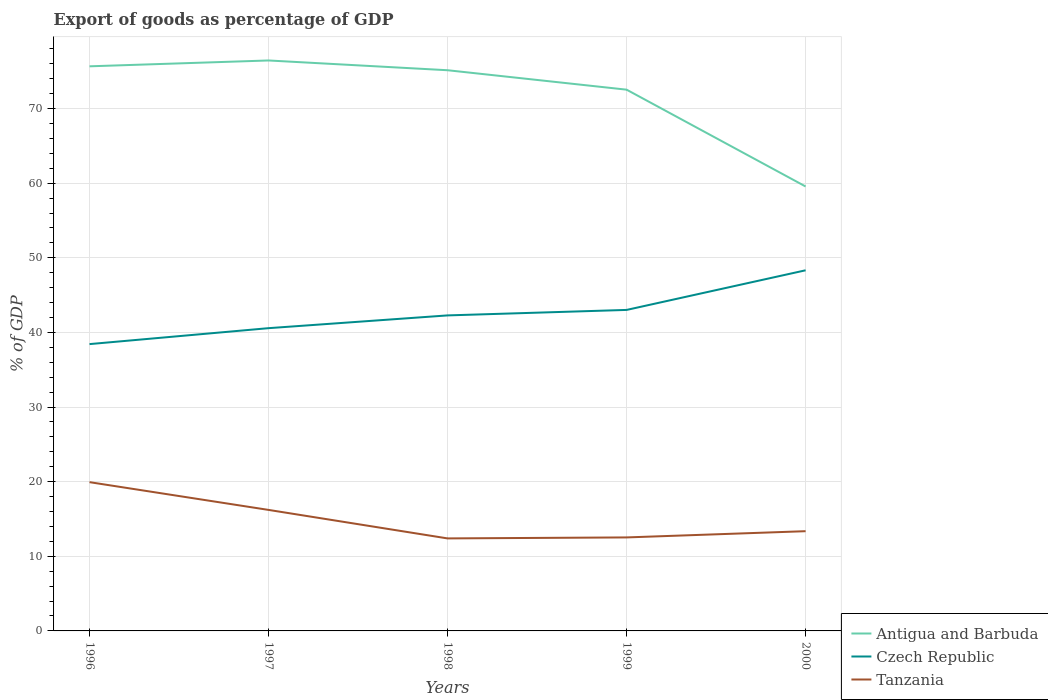How many different coloured lines are there?
Your answer should be compact. 3. Is the number of lines equal to the number of legend labels?
Provide a short and direct response. Yes. Across all years, what is the maximum export of goods as percentage of GDP in Antigua and Barbuda?
Offer a terse response. 59.56. In which year was the export of goods as percentage of GDP in Antigua and Barbuda maximum?
Ensure brevity in your answer.  2000. What is the total export of goods as percentage of GDP in Antigua and Barbuda in the graph?
Give a very brief answer. 3.91. What is the difference between the highest and the second highest export of goods as percentage of GDP in Tanzania?
Offer a very short reply. 7.54. Is the export of goods as percentage of GDP in Tanzania strictly greater than the export of goods as percentage of GDP in Antigua and Barbuda over the years?
Offer a very short reply. Yes. How many lines are there?
Your answer should be compact. 3. What is the difference between two consecutive major ticks on the Y-axis?
Your answer should be very brief. 10. Where does the legend appear in the graph?
Keep it short and to the point. Bottom right. What is the title of the graph?
Your answer should be very brief. Export of goods as percentage of GDP. Does "Vietnam" appear as one of the legend labels in the graph?
Provide a short and direct response. No. What is the label or title of the X-axis?
Ensure brevity in your answer.  Years. What is the label or title of the Y-axis?
Give a very brief answer. % of GDP. What is the % of GDP of Antigua and Barbuda in 1996?
Your answer should be very brief. 75.67. What is the % of GDP in Czech Republic in 1996?
Ensure brevity in your answer.  38.44. What is the % of GDP in Tanzania in 1996?
Your answer should be very brief. 19.94. What is the % of GDP of Antigua and Barbuda in 1997?
Provide a succinct answer. 76.45. What is the % of GDP in Czech Republic in 1997?
Give a very brief answer. 40.57. What is the % of GDP in Tanzania in 1997?
Make the answer very short. 16.22. What is the % of GDP of Antigua and Barbuda in 1998?
Make the answer very short. 75.14. What is the % of GDP of Czech Republic in 1998?
Your response must be concise. 42.28. What is the % of GDP in Tanzania in 1998?
Give a very brief answer. 12.4. What is the % of GDP in Antigua and Barbuda in 1999?
Provide a succinct answer. 72.54. What is the % of GDP of Czech Republic in 1999?
Ensure brevity in your answer.  43.02. What is the % of GDP in Tanzania in 1999?
Offer a very short reply. 12.53. What is the % of GDP in Antigua and Barbuda in 2000?
Your answer should be compact. 59.56. What is the % of GDP of Czech Republic in 2000?
Make the answer very short. 48.33. What is the % of GDP in Tanzania in 2000?
Provide a succinct answer. 13.36. Across all years, what is the maximum % of GDP of Antigua and Barbuda?
Your answer should be very brief. 76.45. Across all years, what is the maximum % of GDP of Czech Republic?
Offer a very short reply. 48.33. Across all years, what is the maximum % of GDP in Tanzania?
Your answer should be very brief. 19.94. Across all years, what is the minimum % of GDP of Antigua and Barbuda?
Keep it short and to the point. 59.56. Across all years, what is the minimum % of GDP of Czech Republic?
Your response must be concise. 38.44. Across all years, what is the minimum % of GDP of Tanzania?
Provide a succinct answer. 12.4. What is the total % of GDP in Antigua and Barbuda in the graph?
Offer a terse response. 359.35. What is the total % of GDP in Czech Republic in the graph?
Offer a very short reply. 212.64. What is the total % of GDP of Tanzania in the graph?
Your response must be concise. 74.45. What is the difference between the % of GDP in Antigua and Barbuda in 1996 and that in 1997?
Your answer should be compact. -0.78. What is the difference between the % of GDP in Czech Republic in 1996 and that in 1997?
Ensure brevity in your answer.  -2.14. What is the difference between the % of GDP in Tanzania in 1996 and that in 1997?
Give a very brief answer. 3.72. What is the difference between the % of GDP in Antigua and Barbuda in 1996 and that in 1998?
Offer a very short reply. 0.53. What is the difference between the % of GDP in Czech Republic in 1996 and that in 1998?
Your response must be concise. -3.85. What is the difference between the % of GDP in Tanzania in 1996 and that in 1998?
Keep it short and to the point. 7.54. What is the difference between the % of GDP of Antigua and Barbuda in 1996 and that in 1999?
Offer a very short reply. 3.13. What is the difference between the % of GDP of Czech Republic in 1996 and that in 1999?
Ensure brevity in your answer.  -4.58. What is the difference between the % of GDP in Tanzania in 1996 and that in 1999?
Give a very brief answer. 7.41. What is the difference between the % of GDP of Antigua and Barbuda in 1996 and that in 2000?
Offer a very short reply. 16.1. What is the difference between the % of GDP of Czech Republic in 1996 and that in 2000?
Your response must be concise. -9.89. What is the difference between the % of GDP in Tanzania in 1996 and that in 2000?
Provide a short and direct response. 6.57. What is the difference between the % of GDP in Antigua and Barbuda in 1997 and that in 1998?
Your response must be concise. 1.31. What is the difference between the % of GDP of Czech Republic in 1997 and that in 1998?
Your response must be concise. -1.71. What is the difference between the % of GDP in Tanzania in 1997 and that in 1998?
Your answer should be very brief. 3.82. What is the difference between the % of GDP of Antigua and Barbuda in 1997 and that in 1999?
Make the answer very short. 3.91. What is the difference between the % of GDP of Czech Republic in 1997 and that in 1999?
Provide a succinct answer. -2.44. What is the difference between the % of GDP of Tanzania in 1997 and that in 1999?
Provide a short and direct response. 3.69. What is the difference between the % of GDP of Antigua and Barbuda in 1997 and that in 2000?
Your response must be concise. 16.89. What is the difference between the % of GDP in Czech Republic in 1997 and that in 2000?
Give a very brief answer. -7.76. What is the difference between the % of GDP of Tanzania in 1997 and that in 2000?
Make the answer very short. 2.85. What is the difference between the % of GDP of Antigua and Barbuda in 1998 and that in 1999?
Your answer should be compact. 2.6. What is the difference between the % of GDP of Czech Republic in 1998 and that in 1999?
Give a very brief answer. -0.74. What is the difference between the % of GDP of Tanzania in 1998 and that in 1999?
Keep it short and to the point. -0.13. What is the difference between the % of GDP of Antigua and Barbuda in 1998 and that in 2000?
Offer a very short reply. 15.58. What is the difference between the % of GDP in Czech Republic in 1998 and that in 2000?
Offer a terse response. -6.05. What is the difference between the % of GDP in Tanzania in 1998 and that in 2000?
Keep it short and to the point. -0.97. What is the difference between the % of GDP in Antigua and Barbuda in 1999 and that in 2000?
Make the answer very short. 12.98. What is the difference between the % of GDP of Czech Republic in 1999 and that in 2000?
Your response must be concise. -5.31. What is the difference between the % of GDP in Tanzania in 1999 and that in 2000?
Your response must be concise. -0.84. What is the difference between the % of GDP in Antigua and Barbuda in 1996 and the % of GDP in Czech Republic in 1997?
Your response must be concise. 35.09. What is the difference between the % of GDP in Antigua and Barbuda in 1996 and the % of GDP in Tanzania in 1997?
Your response must be concise. 59.45. What is the difference between the % of GDP in Czech Republic in 1996 and the % of GDP in Tanzania in 1997?
Your answer should be compact. 22.22. What is the difference between the % of GDP in Antigua and Barbuda in 1996 and the % of GDP in Czech Republic in 1998?
Offer a terse response. 33.38. What is the difference between the % of GDP of Antigua and Barbuda in 1996 and the % of GDP of Tanzania in 1998?
Provide a short and direct response. 63.27. What is the difference between the % of GDP of Czech Republic in 1996 and the % of GDP of Tanzania in 1998?
Provide a succinct answer. 26.04. What is the difference between the % of GDP in Antigua and Barbuda in 1996 and the % of GDP in Czech Republic in 1999?
Keep it short and to the point. 32.65. What is the difference between the % of GDP in Antigua and Barbuda in 1996 and the % of GDP in Tanzania in 1999?
Your response must be concise. 63.14. What is the difference between the % of GDP in Czech Republic in 1996 and the % of GDP in Tanzania in 1999?
Your response must be concise. 25.91. What is the difference between the % of GDP of Antigua and Barbuda in 1996 and the % of GDP of Czech Republic in 2000?
Ensure brevity in your answer.  27.34. What is the difference between the % of GDP in Antigua and Barbuda in 1996 and the % of GDP in Tanzania in 2000?
Your answer should be compact. 62.3. What is the difference between the % of GDP of Czech Republic in 1996 and the % of GDP of Tanzania in 2000?
Your response must be concise. 25.07. What is the difference between the % of GDP of Antigua and Barbuda in 1997 and the % of GDP of Czech Republic in 1998?
Keep it short and to the point. 34.17. What is the difference between the % of GDP of Antigua and Barbuda in 1997 and the % of GDP of Tanzania in 1998?
Ensure brevity in your answer.  64.05. What is the difference between the % of GDP in Czech Republic in 1997 and the % of GDP in Tanzania in 1998?
Provide a succinct answer. 28.18. What is the difference between the % of GDP in Antigua and Barbuda in 1997 and the % of GDP in Czech Republic in 1999?
Offer a terse response. 33.43. What is the difference between the % of GDP in Antigua and Barbuda in 1997 and the % of GDP in Tanzania in 1999?
Offer a terse response. 63.92. What is the difference between the % of GDP of Czech Republic in 1997 and the % of GDP of Tanzania in 1999?
Make the answer very short. 28.04. What is the difference between the % of GDP in Antigua and Barbuda in 1997 and the % of GDP in Czech Republic in 2000?
Your answer should be very brief. 28.12. What is the difference between the % of GDP of Antigua and Barbuda in 1997 and the % of GDP of Tanzania in 2000?
Provide a succinct answer. 63.08. What is the difference between the % of GDP in Czech Republic in 1997 and the % of GDP in Tanzania in 2000?
Give a very brief answer. 27.21. What is the difference between the % of GDP of Antigua and Barbuda in 1998 and the % of GDP of Czech Republic in 1999?
Your answer should be compact. 32.12. What is the difference between the % of GDP in Antigua and Barbuda in 1998 and the % of GDP in Tanzania in 1999?
Offer a very short reply. 62.61. What is the difference between the % of GDP in Czech Republic in 1998 and the % of GDP in Tanzania in 1999?
Your response must be concise. 29.75. What is the difference between the % of GDP of Antigua and Barbuda in 1998 and the % of GDP of Czech Republic in 2000?
Offer a terse response. 26.81. What is the difference between the % of GDP of Antigua and Barbuda in 1998 and the % of GDP of Tanzania in 2000?
Keep it short and to the point. 61.78. What is the difference between the % of GDP of Czech Republic in 1998 and the % of GDP of Tanzania in 2000?
Your response must be concise. 28.92. What is the difference between the % of GDP in Antigua and Barbuda in 1999 and the % of GDP in Czech Republic in 2000?
Your answer should be very brief. 24.21. What is the difference between the % of GDP of Antigua and Barbuda in 1999 and the % of GDP of Tanzania in 2000?
Ensure brevity in your answer.  59.17. What is the difference between the % of GDP of Czech Republic in 1999 and the % of GDP of Tanzania in 2000?
Make the answer very short. 29.65. What is the average % of GDP in Antigua and Barbuda per year?
Provide a succinct answer. 71.87. What is the average % of GDP of Czech Republic per year?
Offer a terse response. 42.53. What is the average % of GDP of Tanzania per year?
Ensure brevity in your answer.  14.89. In the year 1996, what is the difference between the % of GDP of Antigua and Barbuda and % of GDP of Czech Republic?
Offer a very short reply. 37.23. In the year 1996, what is the difference between the % of GDP in Antigua and Barbuda and % of GDP in Tanzania?
Ensure brevity in your answer.  55.73. In the year 1996, what is the difference between the % of GDP in Czech Republic and % of GDP in Tanzania?
Ensure brevity in your answer.  18.5. In the year 1997, what is the difference between the % of GDP of Antigua and Barbuda and % of GDP of Czech Republic?
Give a very brief answer. 35.88. In the year 1997, what is the difference between the % of GDP in Antigua and Barbuda and % of GDP in Tanzania?
Your answer should be very brief. 60.23. In the year 1997, what is the difference between the % of GDP of Czech Republic and % of GDP of Tanzania?
Provide a succinct answer. 24.36. In the year 1998, what is the difference between the % of GDP in Antigua and Barbuda and % of GDP in Czech Republic?
Offer a terse response. 32.86. In the year 1998, what is the difference between the % of GDP in Antigua and Barbuda and % of GDP in Tanzania?
Keep it short and to the point. 62.74. In the year 1998, what is the difference between the % of GDP of Czech Republic and % of GDP of Tanzania?
Ensure brevity in your answer.  29.89. In the year 1999, what is the difference between the % of GDP of Antigua and Barbuda and % of GDP of Czech Republic?
Give a very brief answer. 29.52. In the year 1999, what is the difference between the % of GDP in Antigua and Barbuda and % of GDP in Tanzania?
Offer a terse response. 60.01. In the year 1999, what is the difference between the % of GDP of Czech Republic and % of GDP of Tanzania?
Keep it short and to the point. 30.49. In the year 2000, what is the difference between the % of GDP of Antigua and Barbuda and % of GDP of Czech Republic?
Your answer should be compact. 11.23. In the year 2000, what is the difference between the % of GDP of Antigua and Barbuda and % of GDP of Tanzania?
Your answer should be very brief. 46.2. In the year 2000, what is the difference between the % of GDP of Czech Republic and % of GDP of Tanzania?
Offer a terse response. 34.96. What is the ratio of the % of GDP in Antigua and Barbuda in 1996 to that in 1997?
Give a very brief answer. 0.99. What is the ratio of the % of GDP of Czech Republic in 1996 to that in 1997?
Your answer should be compact. 0.95. What is the ratio of the % of GDP of Tanzania in 1996 to that in 1997?
Offer a very short reply. 1.23. What is the ratio of the % of GDP of Antigua and Barbuda in 1996 to that in 1998?
Make the answer very short. 1.01. What is the ratio of the % of GDP in Tanzania in 1996 to that in 1998?
Ensure brevity in your answer.  1.61. What is the ratio of the % of GDP in Antigua and Barbuda in 1996 to that in 1999?
Make the answer very short. 1.04. What is the ratio of the % of GDP in Czech Republic in 1996 to that in 1999?
Offer a terse response. 0.89. What is the ratio of the % of GDP of Tanzania in 1996 to that in 1999?
Make the answer very short. 1.59. What is the ratio of the % of GDP of Antigua and Barbuda in 1996 to that in 2000?
Ensure brevity in your answer.  1.27. What is the ratio of the % of GDP of Czech Republic in 1996 to that in 2000?
Ensure brevity in your answer.  0.8. What is the ratio of the % of GDP of Tanzania in 1996 to that in 2000?
Your answer should be very brief. 1.49. What is the ratio of the % of GDP in Antigua and Barbuda in 1997 to that in 1998?
Provide a succinct answer. 1.02. What is the ratio of the % of GDP of Czech Republic in 1997 to that in 1998?
Your response must be concise. 0.96. What is the ratio of the % of GDP in Tanzania in 1997 to that in 1998?
Offer a terse response. 1.31. What is the ratio of the % of GDP of Antigua and Barbuda in 1997 to that in 1999?
Ensure brevity in your answer.  1.05. What is the ratio of the % of GDP in Czech Republic in 1997 to that in 1999?
Make the answer very short. 0.94. What is the ratio of the % of GDP of Tanzania in 1997 to that in 1999?
Your answer should be compact. 1.29. What is the ratio of the % of GDP in Antigua and Barbuda in 1997 to that in 2000?
Your answer should be very brief. 1.28. What is the ratio of the % of GDP of Czech Republic in 1997 to that in 2000?
Your response must be concise. 0.84. What is the ratio of the % of GDP of Tanzania in 1997 to that in 2000?
Give a very brief answer. 1.21. What is the ratio of the % of GDP of Antigua and Barbuda in 1998 to that in 1999?
Your answer should be compact. 1.04. What is the ratio of the % of GDP in Czech Republic in 1998 to that in 1999?
Your answer should be very brief. 0.98. What is the ratio of the % of GDP in Antigua and Barbuda in 1998 to that in 2000?
Ensure brevity in your answer.  1.26. What is the ratio of the % of GDP of Czech Republic in 1998 to that in 2000?
Ensure brevity in your answer.  0.87. What is the ratio of the % of GDP in Tanzania in 1998 to that in 2000?
Offer a terse response. 0.93. What is the ratio of the % of GDP in Antigua and Barbuda in 1999 to that in 2000?
Provide a succinct answer. 1.22. What is the ratio of the % of GDP in Czech Republic in 1999 to that in 2000?
Provide a short and direct response. 0.89. What is the difference between the highest and the second highest % of GDP of Antigua and Barbuda?
Your response must be concise. 0.78. What is the difference between the highest and the second highest % of GDP of Czech Republic?
Provide a short and direct response. 5.31. What is the difference between the highest and the second highest % of GDP of Tanzania?
Your response must be concise. 3.72. What is the difference between the highest and the lowest % of GDP of Antigua and Barbuda?
Offer a terse response. 16.89. What is the difference between the highest and the lowest % of GDP of Czech Republic?
Provide a short and direct response. 9.89. What is the difference between the highest and the lowest % of GDP in Tanzania?
Make the answer very short. 7.54. 